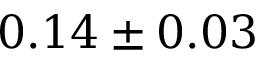Convert formula to latex. <formula><loc_0><loc_0><loc_500><loc_500>0 . 1 4 \pm 0 . 0 3</formula> 